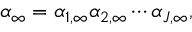Convert formula to latex. <formula><loc_0><loc_0><loc_500><loc_500>\alpha _ { \infty } = \alpha _ { 1 , \infty } \alpha _ { 2 , \infty } \cdots \alpha _ { J , \infty } ,</formula> 